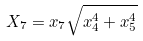<formula> <loc_0><loc_0><loc_500><loc_500>X _ { 7 } = x _ { 7 } \sqrt { x _ { 4 } ^ { 4 } + x _ { 5 } ^ { 4 } }</formula> 